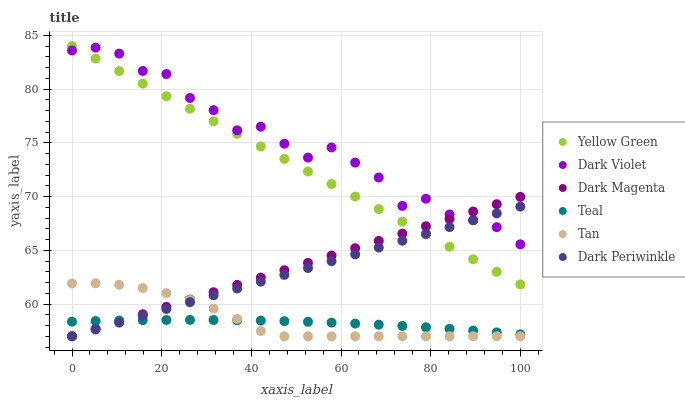Does Teal have the minimum area under the curve?
Answer yes or no. Yes. Does Dark Violet have the maximum area under the curve?
Answer yes or no. Yes. Does Dark Violet have the minimum area under the curve?
Answer yes or no. No. Does Teal have the maximum area under the curve?
Answer yes or no. No. Is Dark Periwinkle the smoothest?
Answer yes or no. Yes. Is Dark Violet the roughest?
Answer yes or no. Yes. Is Teal the smoothest?
Answer yes or no. No. Is Teal the roughest?
Answer yes or no. No. Does Tan have the lowest value?
Answer yes or no. Yes. Does Teal have the lowest value?
Answer yes or no. No. Does Yellow Green have the highest value?
Answer yes or no. Yes. Does Dark Violet have the highest value?
Answer yes or no. No. Is Teal less than Yellow Green?
Answer yes or no. Yes. Is Yellow Green greater than Tan?
Answer yes or no. Yes. Does Dark Periwinkle intersect Teal?
Answer yes or no. Yes. Is Dark Periwinkle less than Teal?
Answer yes or no. No. Is Dark Periwinkle greater than Teal?
Answer yes or no. No. Does Teal intersect Yellow Green?
Answer yes or no. No. 